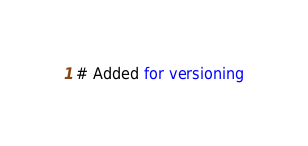Convert code to text. <code><loc_0><loc_0><loc_500><loc_500><_SQL_># Added for versioning</code> 